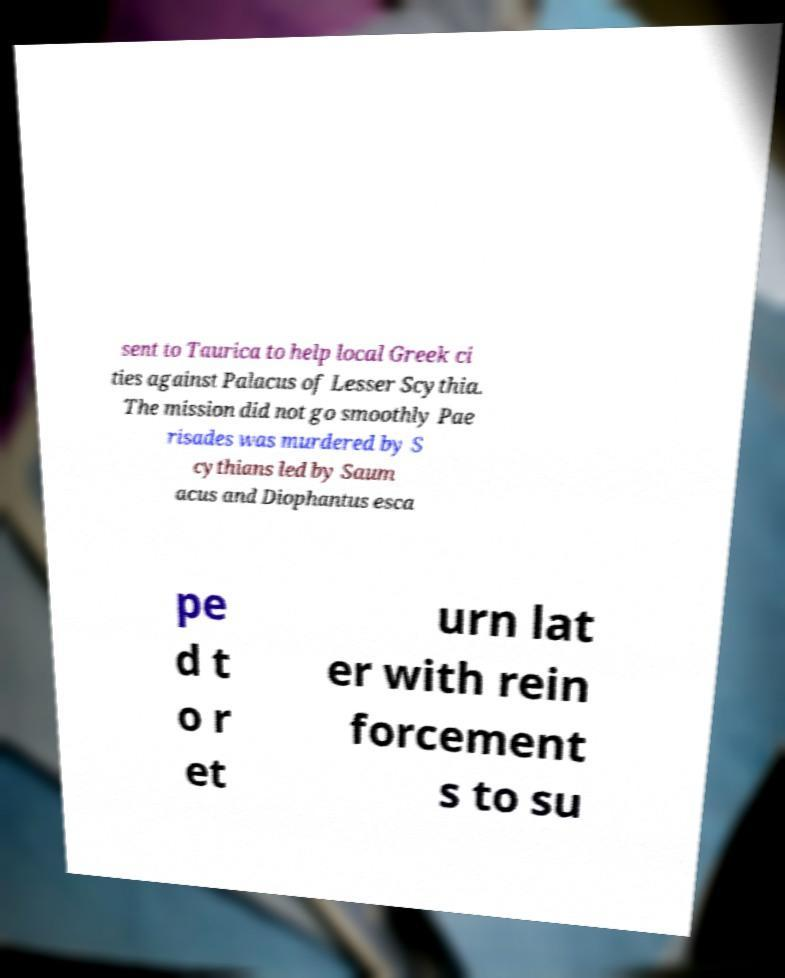Please identify and transcribe the text found in this image. sent to Taurica to help local Greek ci ties against Palacus of Lesser Scythia. The mission did not go smoothly Pae risades was murdered by S cythians led by Saum acus and Diophantus esca pe d t o r et urn lat er with rein forcement s to su 